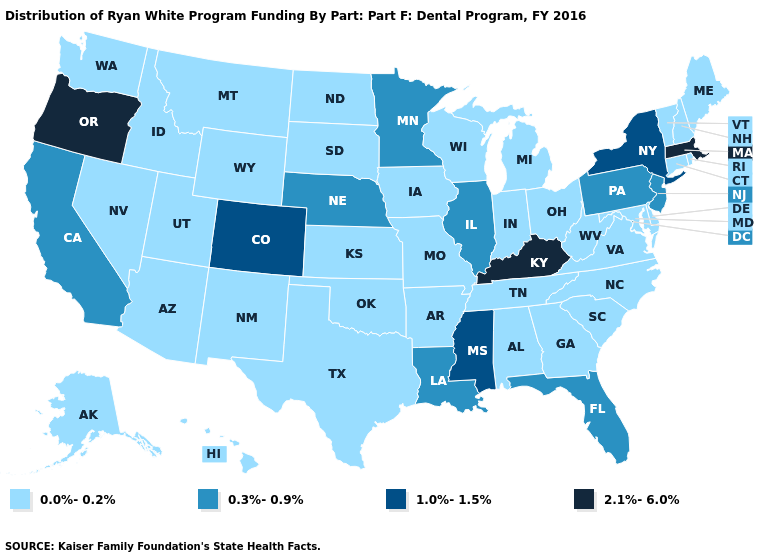Name the states that have a value in the range 0.3%-0.9%?
Write a very short answer. California, Florida, Illinois, Louisiana, Minnesota, Nebraska, New Jersey, Pennsylvania. Which states hav the highest value in the West?
Concise answer only. Oregon. Does Delaware have the same value as Kentucky?
Quick response, please. No. What is the value of Pennsylvania?
Keep it brief. 0.3%-0.9%. What is the lowest value in the USA?
Quick response, please. 0.0%-0.2%. What is the value of Maryland?
Keep it brief. 0.0%-0.2%. What is the lowest value in states that border New Jersey?
Answer briefly. 0.0%-0.2%. What is the highest value in the USA?
Give a very brief answer. 2.1%-6.0%. What is the value of Iowa?
Be succinct. 0.0%-0.2%. Does the map have missing data?
Write a very short answer. No. What is the value of Delaware?
Write a very short answer. 0.0%-0.2%. Does Arizona have the highest value in the West?
Give a very brief answer. No. What is the value of Kansas?
Keep it brief. 0.0%-0.2%. What is the value of North Carolina?
Answer briefly. 0.0%-0.2%. Is the legend a continuous bar?
Write a very short answer. No. 